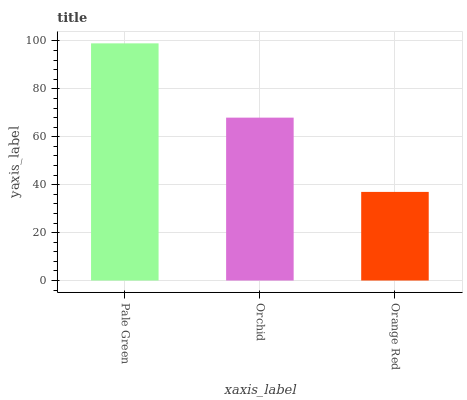Is Orange Red the minimum?
Answer yes or no. Yes. Is Pale Green the maximum?
Answer yes or no. Yes. Is Orchid the minimum?
Answer yes or no. No. Is Orchid the maximum?
Answer yes or no. No. Is Pale Green greater than Orchid?
Answer yes or no. Yes. Is Orchid less than Pale Green?
Answer yes or no. Yes. Is Orchid greater than Pale Green?
Answer yes or no. No. Is Pale Green less than Orchid?
Answer yes or no. No. Is Orchid the high median?
Answer yes or no. Yes. Is Orchid the low median?
Answer yes or no. Yes. Is Pale Green the high median?
Answer yes or no. No. Is Orange Red the low median?
Answer yes or no. No. 